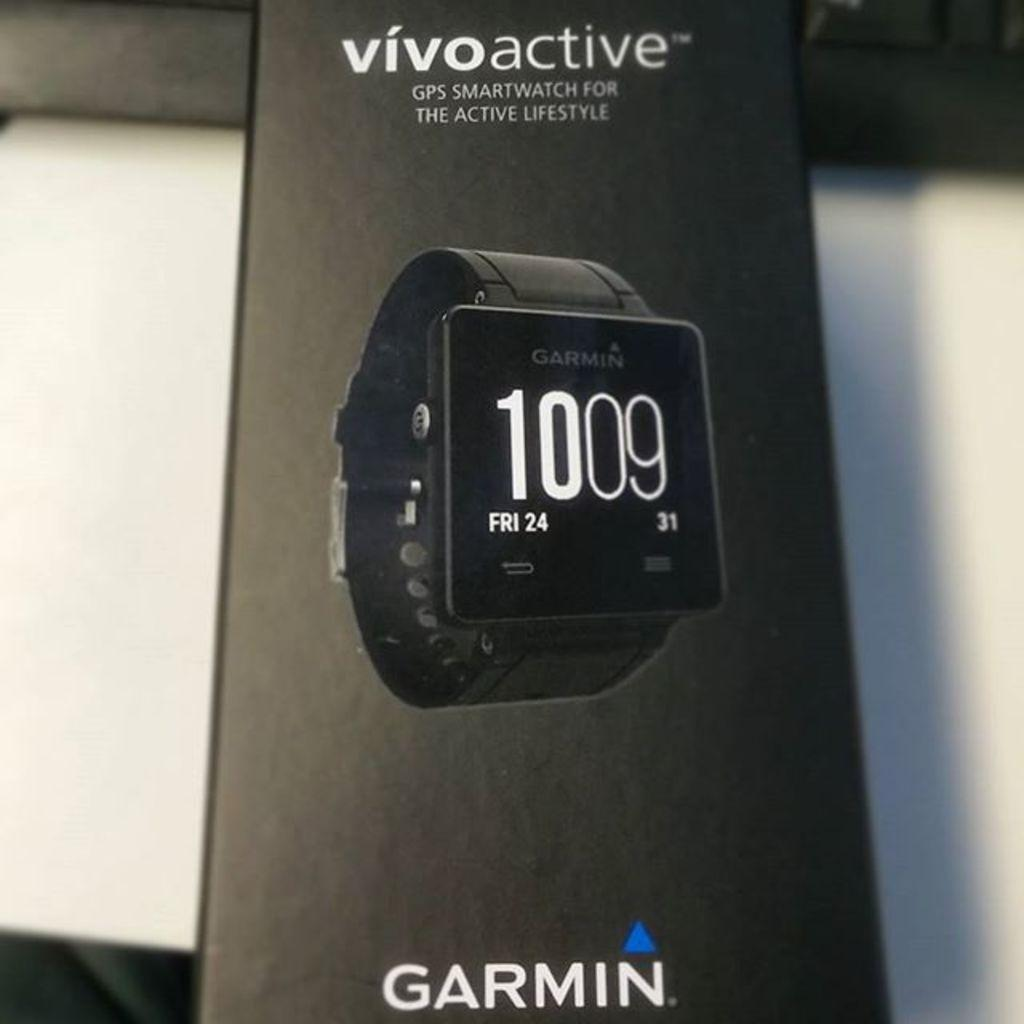<image>
Write a terse but informative summary of the picture. A display for a Garmin fintess watch which proclaims it is for the active lifestyle. 